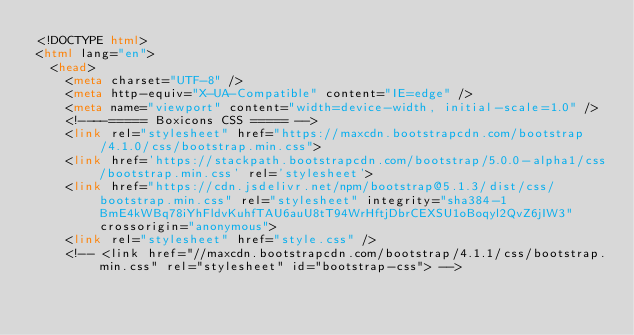<code> <loc_0><loc_0><loc_500><loc_500><_HTML_><!DOCTYPE html>
<html lang="en">
  <head>
    <meta charset="UTF-8" />
    <meta http-equiv="X-UA-Compatible" content="IE=edge" />
    <meta name="viewport" content="width=device-width, initial-scale=1.0" />
    <!----===== Boxicons CSS ===== -->
    <link rel="stylesheet" href="https://maxcdn.bootstrapcdn.com/bootstrap/4.1.0/css/bootstrap.min.css">
    <link href='https://stackpath.bootstrapcdn.com/bootstrap/5.0.0-alpha1/css/bootstrap.min.css' rel='stylesheet'>
    <link href="https://cdn.jsdelivr.net/npm/bootstrap@5.1.3/dist/css/bootstrap.min.css" rel="stylesheet" integrity="sha384-1BmE4kWBq78iYhFldvKuhfTAU6auU8tT94WrHftjDbrCEXSU1oBoqyl2QvZ6jIW3" crossorigin="anonymous">
    <link rel="stylesheet" href="style.css" />
    <!-- <link href="//maxcdn.bootstrapcdn.com/bootstrap/4.1.1/css/bootstrap.min.css" rel="stylesheet" id="bootstrap-css"> --></code> 